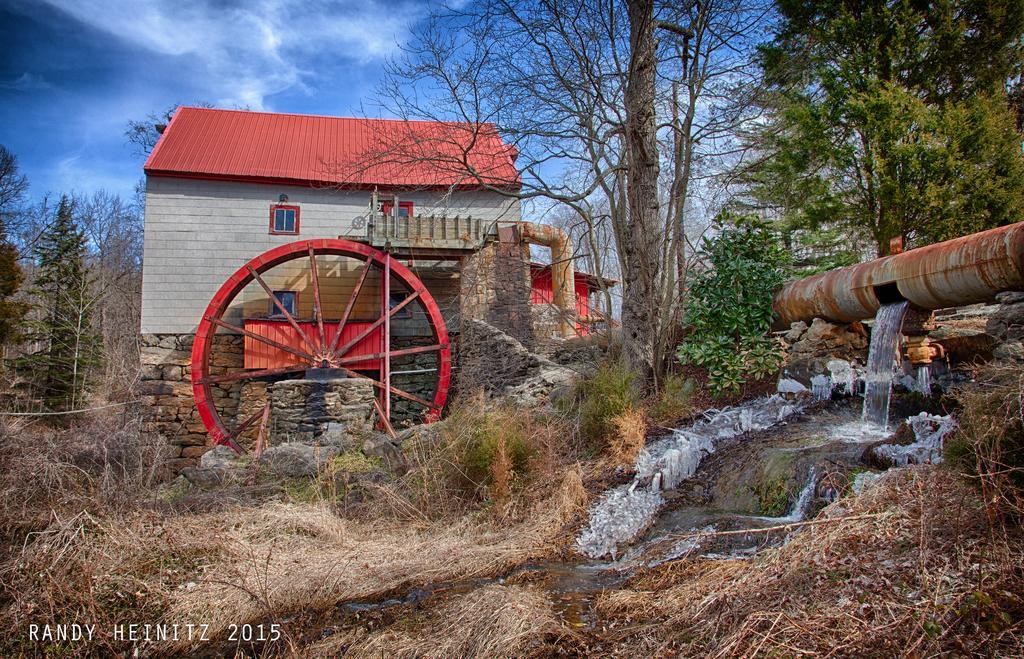Can you describe this image briefly? In this image, we can see a house, wheel, pipes, plants, grass, trees. Right side of the image, we can see a water flow. At the bottom of the image, we can see a watermark. Top of the image, there is a sky. 